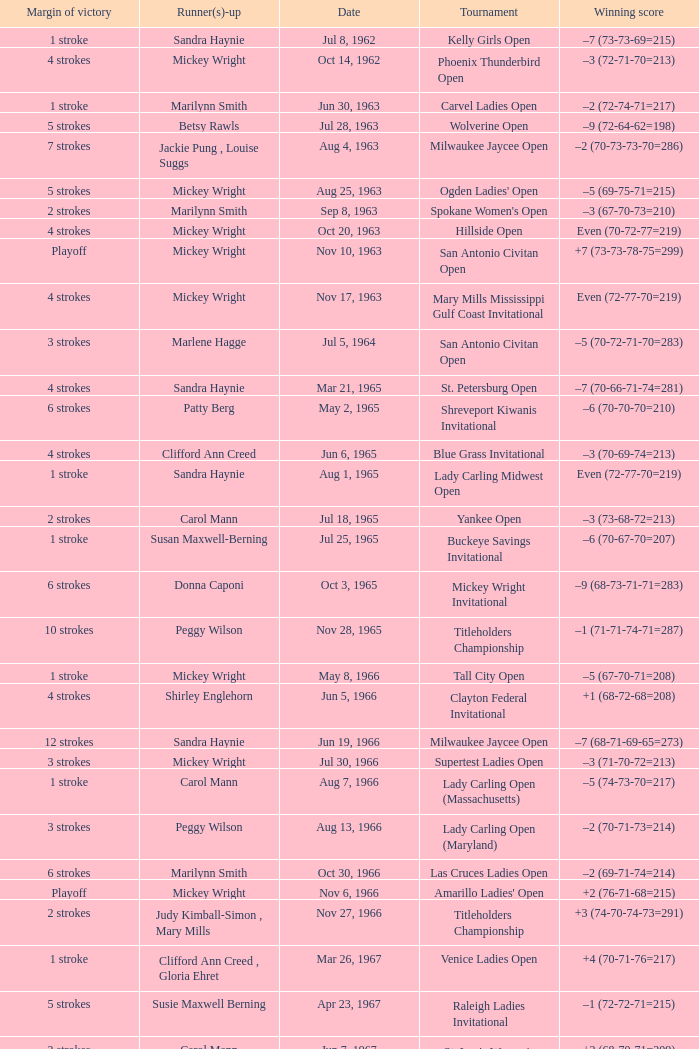What was the winning score when there were 9 strokes advantage? –7 (73-68-73-67=281). 